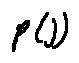<formula> <loc_0><loc_0><loc_500><loc_500>p ( j )</formula> 